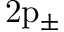Convert formula to latex. <formula><loc_0><loc_0><loc_500><loc_500>2 \mathrm { p } _ { \pm }</formula> 